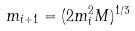<formula> <loc_0><loc_0><loc_500><loc_500>m _ { i + 1 } = ( 2 m _ { i } ^ { 2 } M ) ^ { 1 / 3 }</formula> 